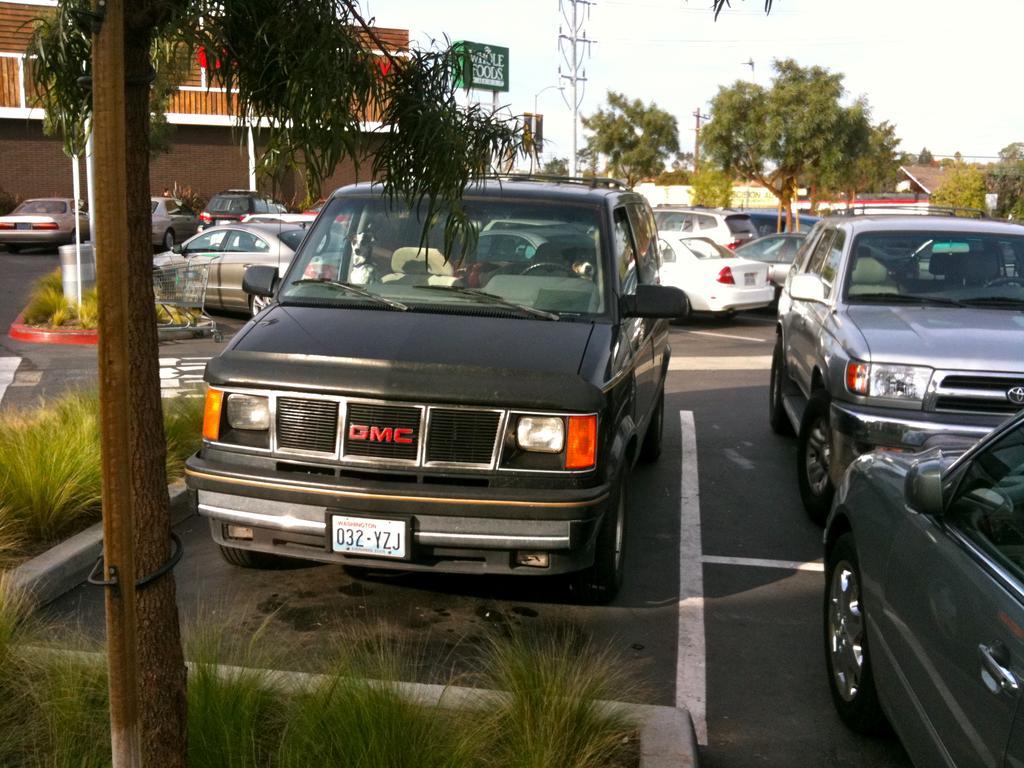How would you summarize this image in a sentence or two? In this picture we can see vehicles on the road, plants, trees, buildings, name board, some objects and in the background we can see the sky. 